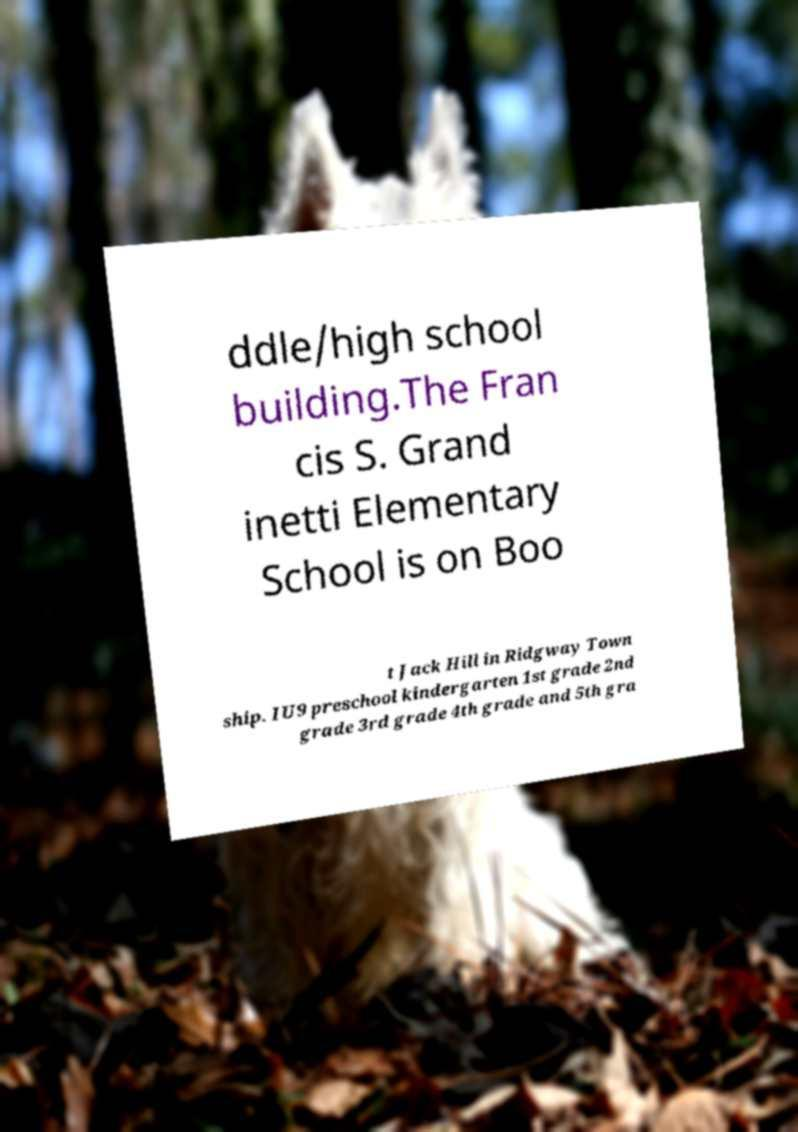What messages or text are displayed in this image? I need them in a readable, typed format. ddle/high school building.The Fran cis S. Grand inetti Elementary School is on Boo t Jack Hill in Ridgway Town ship. IU9 preschool kindergarten 1st grade 2nd grade 3rd grade 4th grade and 5th gra 